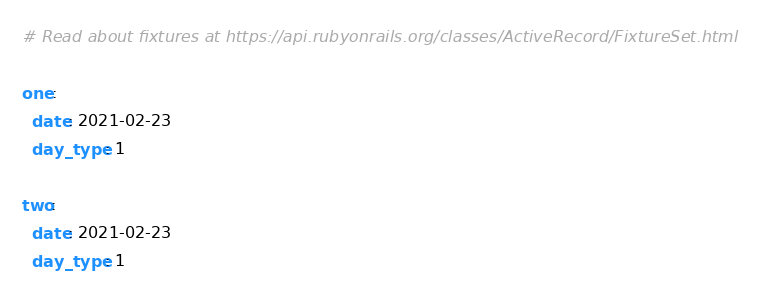<code> <loc_0><loc_0><loc_500><loc_500><_YAML_># Read about fixtures at https://api.rubyonrails.org/classes/ActiveRecord/FixtureSet.html

one:
  date: 2021-02-23
  day_type: 1

two:
  date: 2021-02-23
  day_type: 1
</code> 